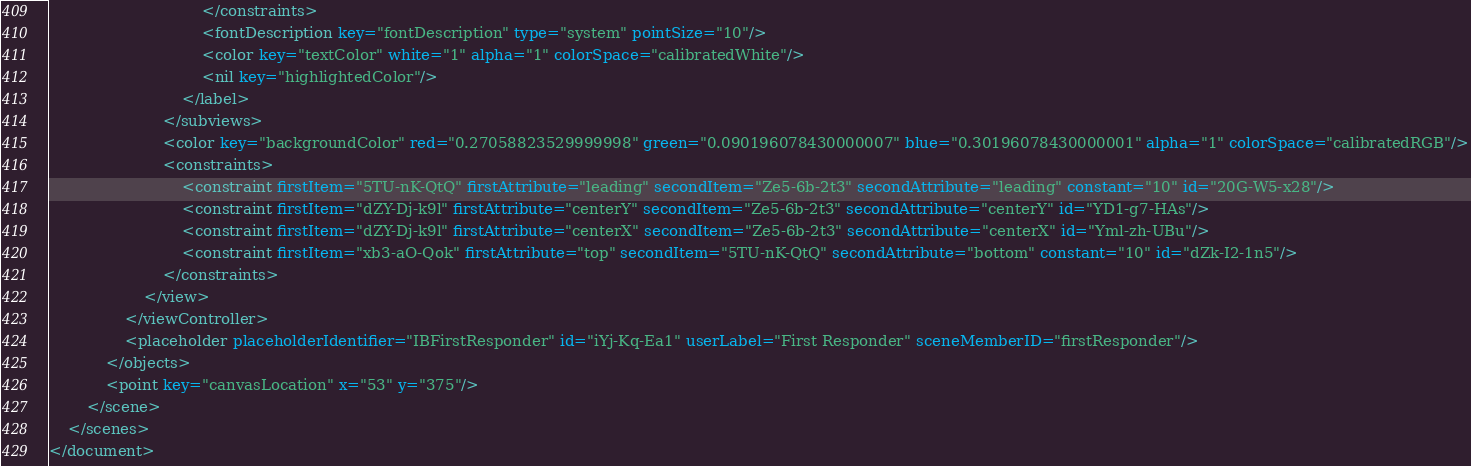<code> <loc_0><loc_0><loc_500><loc_500><_XML_>                                </constraints>
                                <fontDescription key="fontDescription" type="system" pointSize="10"/>
                                <color key="textColor" white="1" alpha="1" colorSpace="calibratedWhite"/>
                                <nil key="highlightedColor"/>
                            </label>
                        </subviews>
                        <color key="backgroundColor" red="0.27058823529999998" green="0.090196078430000007" blue="0.30196078430000001" alpha="1" colorSpace="calibratedRGB"/>
                        <constraints>
                            <constraint firstItem="5TU-nK-QtQ" firstAttribute="leading" secondItem="Ze5-6b-2t3" secondAttribute="leading" constant="10" id="20G-W5-x28"/>
                            <constraint firstItem="dZY-Dj-k9l" firstAttribute="centerY" secondItem="Ze5-6b-2t3" secondAttribute="centerY" id="YD1-g7-HAs"/>
                            <constraint firstItem="dZY-Dj-k9l" firstAttribute="centerX" secondItem="Ze5-6b-2t3" secondAttribute="centerX" id="Yml-zh-UBu"/>
                            <constraint firstItem="xb3-aO-Qok" firstAttribute="top" secondItem="5TU-nK-QtQ" secondAttribute="bottom" constant="10" id="dZk-I2-1n5"/>
                        </constraints>
                    </view>
                </viewController>
                <placeholder placeholderIdentifier="IBFirstResponder" id="iYj-Kq-Ea1" userLabel="First Responder" sceneMemberID="firstResponder"/>
            </objects>
            <point key="canvasLocation" x="53" y="375"/>
        </scene>
    </scenes>
</document>
</code> 